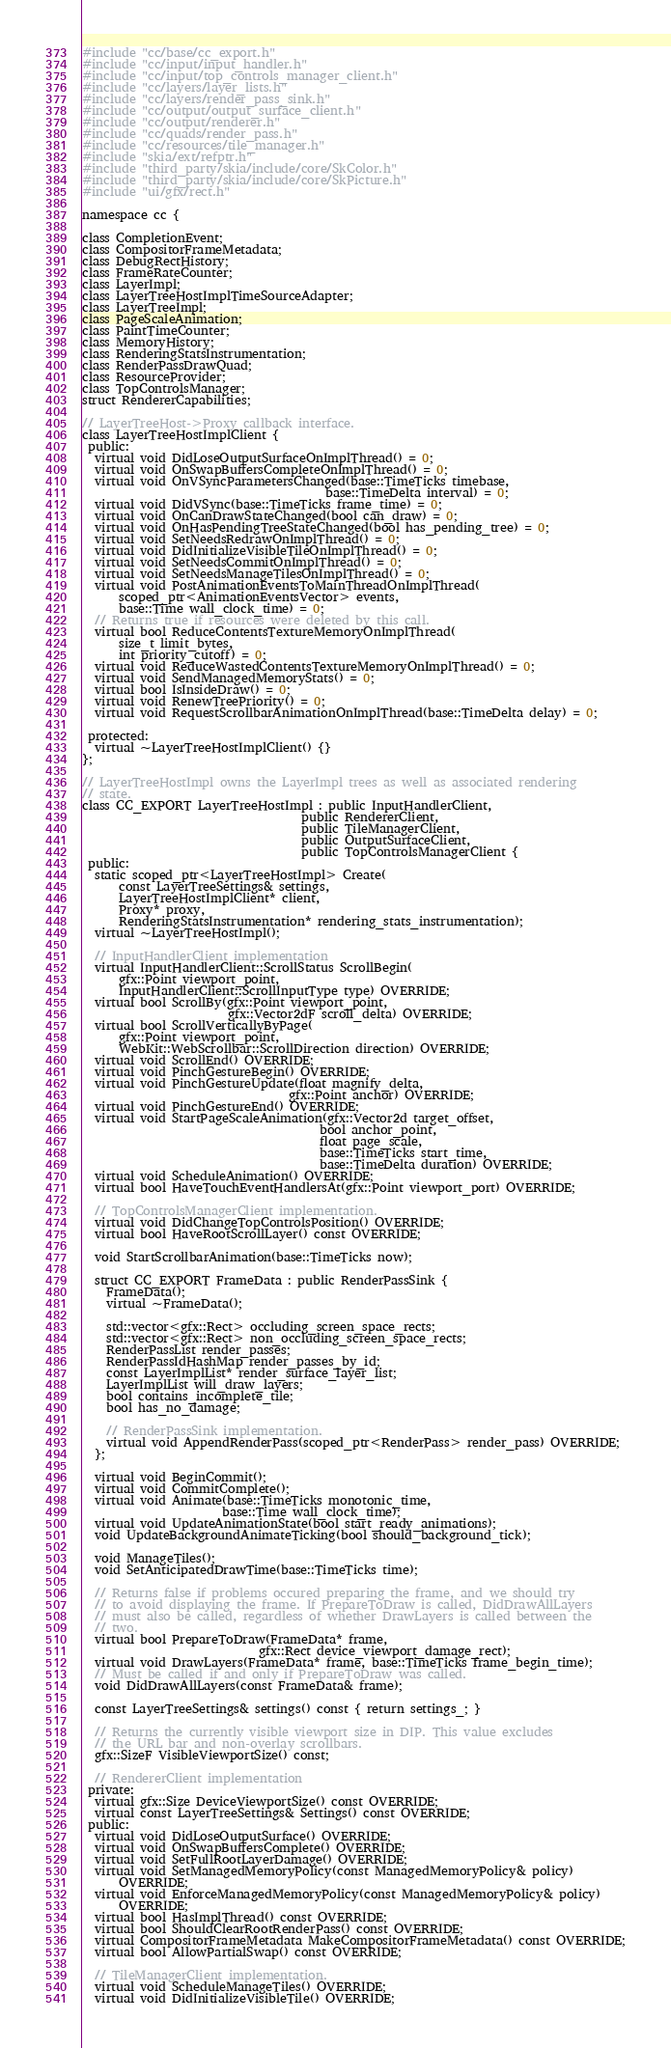Convert code to text. <code><loc_0><loc_0><loc_500><loc_500><_C_>#include "cc/base/cc_export.h"
#include "cc/input/input_handler.h"
#include "cc/input/top_controls_manager_client.h"
#include "cc/layers/layer_lists.h"
#include "cc/layers/render_pass_sink.h"
#include "cc/output/output_surface_client.h"
#include "cc/output/renderer.h"
#include "cc/quads/render_pass.h"
#include "cc/resources/tile_manager.h"
#include "skia/ext/refptr.h"
#include "third_party/skia/include/core/SkColor.h"
#include "third_party/skia/include/core/SkPicture.h"
#include "ui/gfx/rect.h"

namespace cc {

class CompletionEvent;
class CompositorFrameMetadata;
class DebugRectHistory;
class FrameRateCounter;
class LayerImpl;
class LayerTreeHostImplTimeSourceAdapter;
class LayerTreeImpl;
class PageScaleAnimation;
class PaintTimeCounter;
class MemoryHistory;
class RenderingStatsInstrumentation;
class RenderPassDrawQuad;
class ResourceProvider;
class TopControlsManager;
struct RendererCapabilities;

// LayerTreeHost->Proxy callback interface.
class LayerTreeHostImplClient {
 public:
  virtual void DidLoseOutputSurfaceOnImplThread() = 0;
  virtual void OnSwapBuffersCompleteOnImplThread() = 0;
  virtual void OnVSyncParametersChanged(base::TimeTicks timebase,
                                        base::TimeDelta interval) = 0;
  virtual void DidVSync(base::TimeTicks frame_time) = 0;
  virtual void OnCanDrawStateChanged(bool can_draw) = 0;
  virtual void OnHasPendingTreeStateChanged(bool has_pending_tree) = 0;
  virtual void SetNeedsRedrawOnImplThread() = 0;
  virtual void DidInitializeVisibleTileOnImplThread() = 0;
  virtual void SetNeedsCommitOnImplThread() = 0;
  virtual void SetNeedsManageTilesOnImplThread() = 0;
  virtual void PostAnimationEventsToMainThreadOnImplThread(
      scoped_ptr<AnimationEventsVector> events,
      base::Time wall_clock_time) = 0;
  // Returns true if resources were deleted by this call.
  virtual bool ReduceContentsTextureMemoryOnImplThread(
      size_t limit_bytes,
      int priority_cutoff) = 0;
  virtual void ReduceWastedContentsTextureMemoryOnImplThread() = 0;
  virtual void SendManagedMemoryStats() = 0;
  virtual bool IsInsideDraw() = 0;
  virtual void RenewTreePriority() = 0;
  virtual void RequestScrollbarAnimationOnImplThread(base::TimeDelta delay) = 0;

 protected:
  virtual ~LayerTreeHostImplClient() {}
};

// LayerTreeHostImpl owns the LayerImpl trees as well as associated rendering
// state.
class CC_EXPORT LayerTreeHostImpl : public InputHandlerClient,
                                    public RendererClient,
                                    public TileManagerClient,
                                    public OutputSurfaceClient,
                                    public TopControlsManagerClient {
 public:
  static scoped_ptr<LayerTreeHostImpl> Create(
      const LayerTreeSettings& settings,
      LayerTreeHostImplClient* client,
      Proxy* proxy,
      RenderingStatsInstrumentation* rendering_stats_instrumentation);
  virtual ~LayerTreeHostImpl();

  // InputHandlerClient implementation
  virtual InputHandlerClient::ScrollStatus ScrollBegin(
      gfx::Point viewport_point,
      InputHandlerClient::ScrollInputType type) OVERRIDE;
  virtual bool ScrollBy(gfx::Point viewport_point,
                        gfx::Vector2dF scroll_delta) OVERRIDE;
  virtual bool ScrollVerticallyByPage(
      gfx::Point viewport_point,
      WebKit::WebScrollbar::ScrollDirection direction) OVERRIDE;
  virtual void ScrollEnd() OVERRIDE;
  virtual void PinchGestureBegin() OVERRIDE;
  virtual void PinchGestureUpdate(float magnify_delta,
                                  gfx::Point anchor) OVERRIDE;
  virtual void PinchGestureEnd() OVERRIDE;
  virtual void StartPageScaleAnimation(gfx::Vector2d target_offset,
                                       bool anchor_point,
                                       float page_scale,
                                       base::TimeTicks start_time,
                                       base::TimeDelta duration) OVERRIDE;
  virtual void ScheduleAnimation() OVERRIDE;
  virtual bool HaveTouchEventHandlersAt(gfx::Point viewport_port) OVERRIDE;

  // TopControlsManagerClient implementation.
  virtual void DidChangeTopControlsPosition() OVERRIDE;
  virtual bool HaveRootScrollLayer() const OVERRIDE;

  void StartScrollbarAnimation(base::TimeTicks now);

  struct CC_EXPORT FrameData : public RenderPassSink {
    FrameData();
    virtual ~FrameData();

    std::vector<gfx::Rect> occluding_screen_space_rects;
    std::vector<gfx::Rect> non_occluding_screen_space_rects;
    RenderPassList render_passes;
    RenderPassIdHashMap render_passes_by_id;
    const LayerImplList* render_surface_layer_list;
    LayerImplList will_draw_layers;
    bool contains_incomplete_tile;
    bool has_no_damage;

    // RenderPassSink implementation.
    virtual void AppendRenderPass(scoped_ptr<RenderPass> render_pass) OVERRIDE;
  };

  virtual void BeginCommit();
  virtual void CommitComplete();
  virtual void Animate(base::TimeTicks monotonic_time,
                       base::Time wall_clock_time);
  virtual void UpdateAnimationState(bool start_ready_animations);
  void UpdateBackgroundAnimateTicking(bool should_background_tick);

  void ManageTiles();
  void SetAnticipatedDrawTime(base::TimeTicks time);

  // Returns false if problems occured preparing the frame, and we should try
  // to avoid displaying the frame. If PrepareToDraw is called, DidDrawAllLayers
  // must also be called, regardless of whether DrawLayers is called between the
  // two.
  virtual bool PrepareToDraw(FrameData* frame,
                             gfx::Rect device_viewport_damage_rect);
  virtual void DrawLayers(FrameData* frame, base::TimeTicks frame_begin_time);
  // Must be called if and only if PrepareToDraw was called.
  void DidDrawAllLayers(const FrameData& frame);

  const LayerTreeSettings& settings() const { return settings_; }

  // Returns the currently visible viewport size in DIP. This value excludes
  // the URL bar and non-overlay scrollbars.
  gfx::SizeF VisibleViewportSize() const;

  // RendererClient implementation
 private:
  virtual gfx::Size DeviceViewportSize() const OVERRIDE;
  virtual const LayerTreeSettings& Settings() const OVERRIDE;
 public:
  virtual void DidLoseOutputSurface() OVERRIDE;
  virtual void OnSwapBuffersComplete() OVERRIDE;
  virtual void SetFullRootLayerDamage() OVERRIDE;
  virtual void SetManagedMemoryPolicy(const ManagedMemoryPolicy& policy)
      OVERRIDE;
  virtual void EnforceManagedMemoryPolicy(const ManagedMemoryPolicy& policy)
      OVERRIDE;
  virtual bool HasImplThread() const OVERRIDE;
  virtual bool ShouldClearRootRenderPass() const OVERRIDE;
  virtual CompositorFrameMetadata MakeCompositorFrameMetadata() const OVERRIDE;
  virtual bool AllowPartialSwap() const OVERRIDE;

  // TileManagerClient implementation.
  virtual void ScheduleManageTiles() OVERRIDE;
  virtual void DidInitializeVisibleTile() OVERRIDE;
</code> 